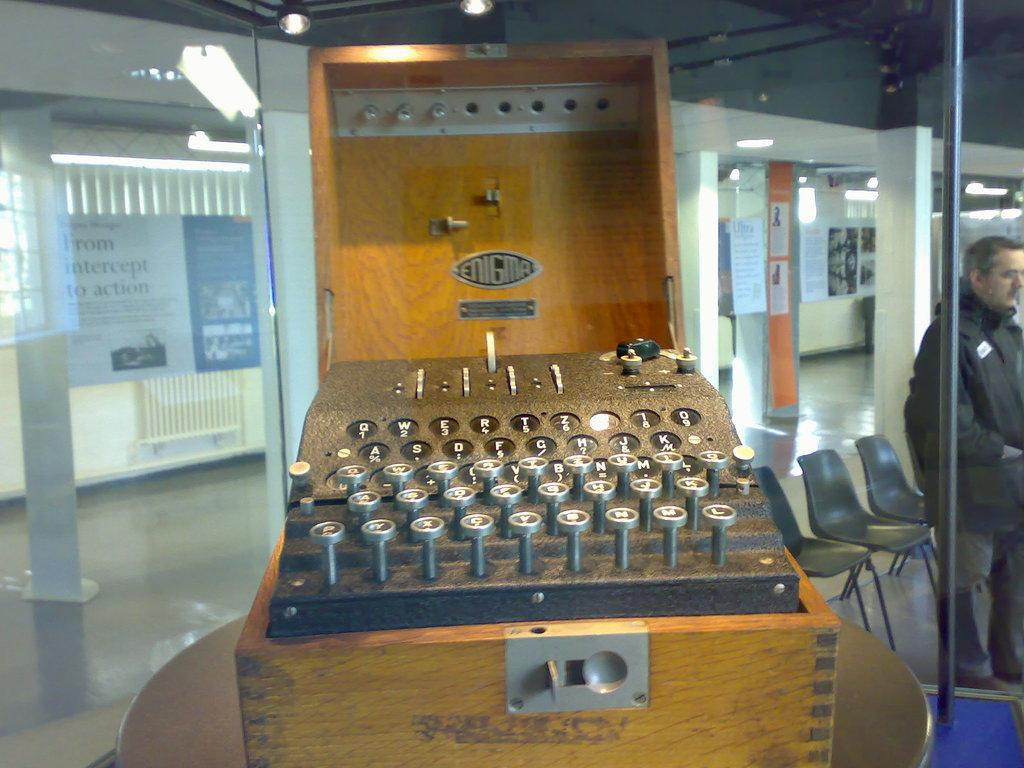<image>
Render a clear and concise summary of the photo. An old fashioned Enigma machine with silver keys in a wooden box. 